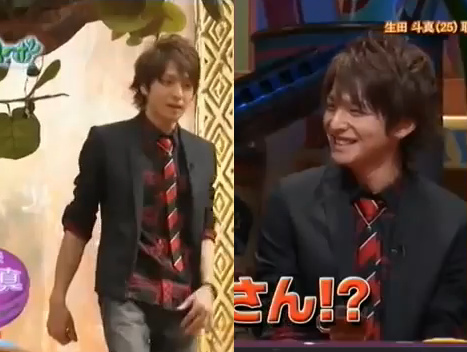Who is wearing the coat? The man is wearing the coat. 